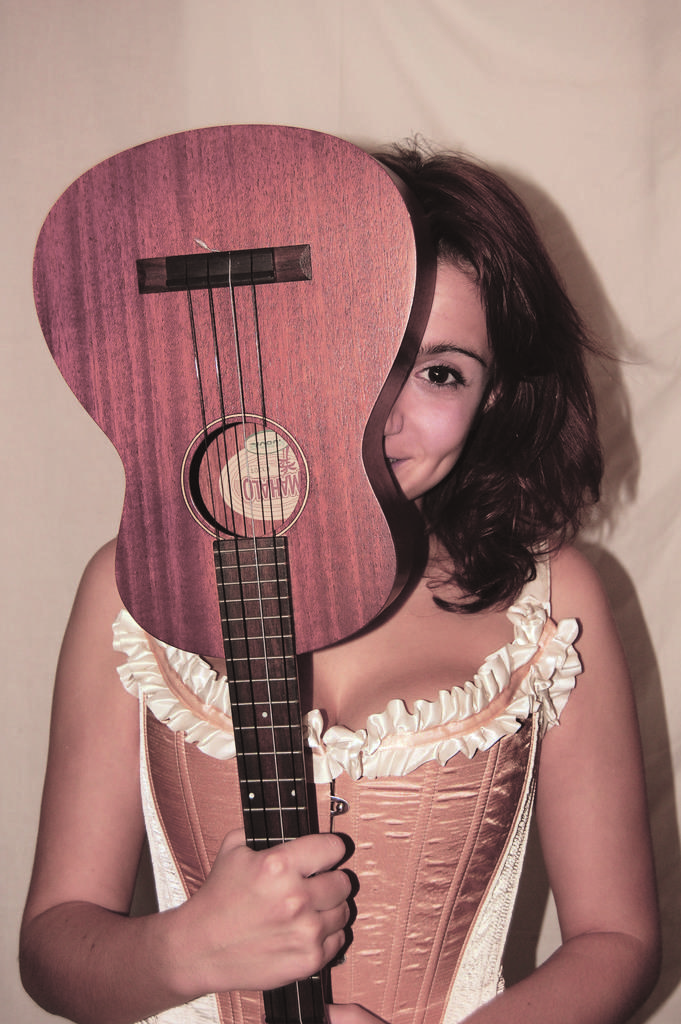What is the main subject of the image? The main subject of the image is a woman. What is the woman holding in the image? The woman is holding a guitar. What expression does the woman have in the image? The woman is smiling. What type of detail can be seen on the woman's secretary's desk in the image? There is no secretary or desk present in the image; it features a woman holding a guitar and smiling. 